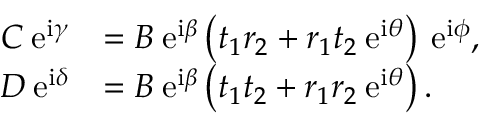<formula> <loc_0><loc_0><loc_500><loc_500>\begin{array} { r l } { C \, e ^ { i \gamma } } & { = B \, e ^ { i \beta } \left ( t _ { 1 } r _ { 2 } + r _ { 1 } t _ { 2 } \, e ^ { i \theta } \right ) \, e ^ { i \phi } , } \\ { D \, e ^ { i \delta } } & { = B \, e ^ { i \beta } \left ( t _ { 1 } t _ { 2 } + r _ { 1 } r _ { 2 } \, e ^ { i \theta } \right ) . } \end{array}</formula> 